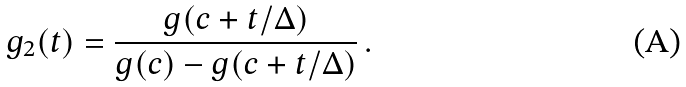<formula> <loc_0><loc_0><loc_500><loc_500>g _ { 2 } ( t ) = \frac { g ( c + t / \Delta ) } { g ( c ) - g ( c + t / \Delta ) } \, .</formula> 